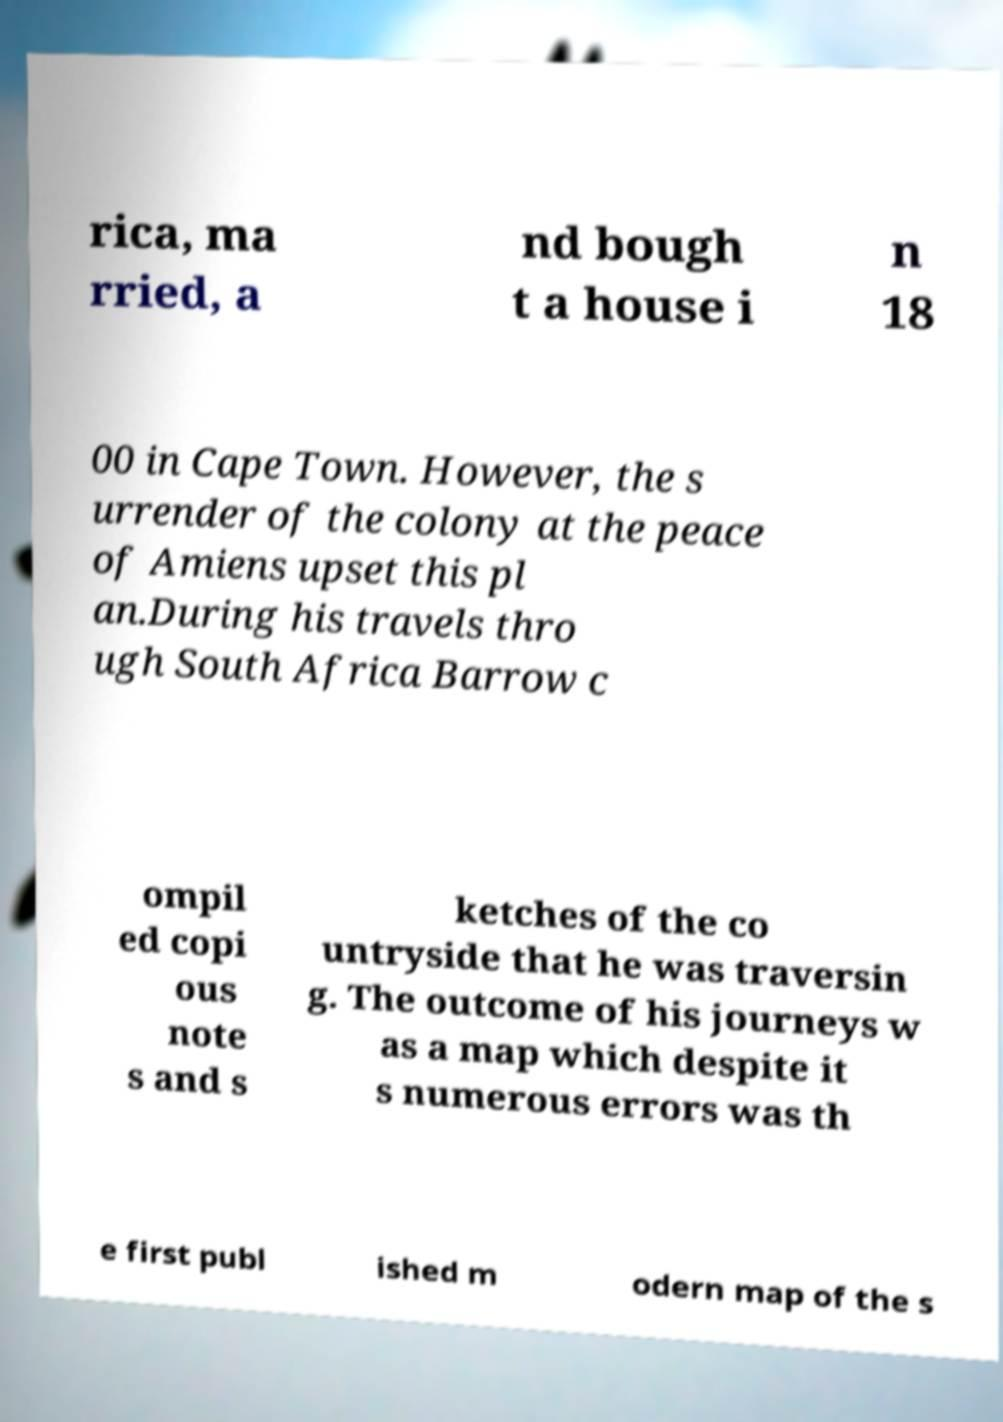Please read and relay the text visible in this image. What does it say? rica, ma rried, a nd bough t a house i n 18 00 in Cape Town. However, the s urrender of the colony at the peace of Amiens upset this pl an.During his travels thro ugh South Africa Barrow c ompil ed copi ous note s and s ketches of the co untryside that he was traversin g. The outcome of his journeys w as a map which despite it s numerous errors was th e first publ ished m odern map of the s 